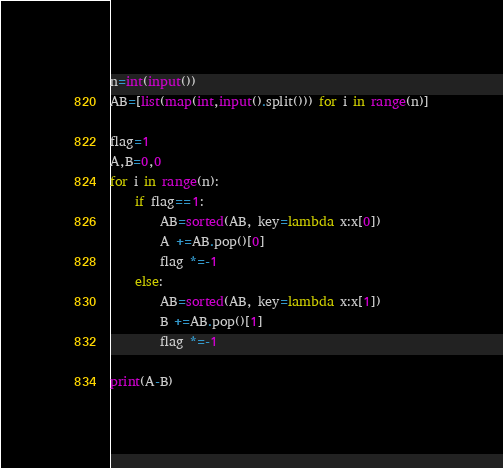<code> <loc_0><loc_0><loc_500><loc_500><_Python_>n=int(input())
AB=[list(map(int,input().split())) for i in range(n)]

flag=1
A,B=0,0
for i in range(n):
    if flag==1:
        AB=sorted(AB, key=lambda x:x[0])
        A +=AB.pop()[0]
        flag *=-1
    else:
        AB=sorted(AB, key=lambda x:x[1])
        B +=AB.pop()[1]
        flag *=-1

print(A-B)</code> 